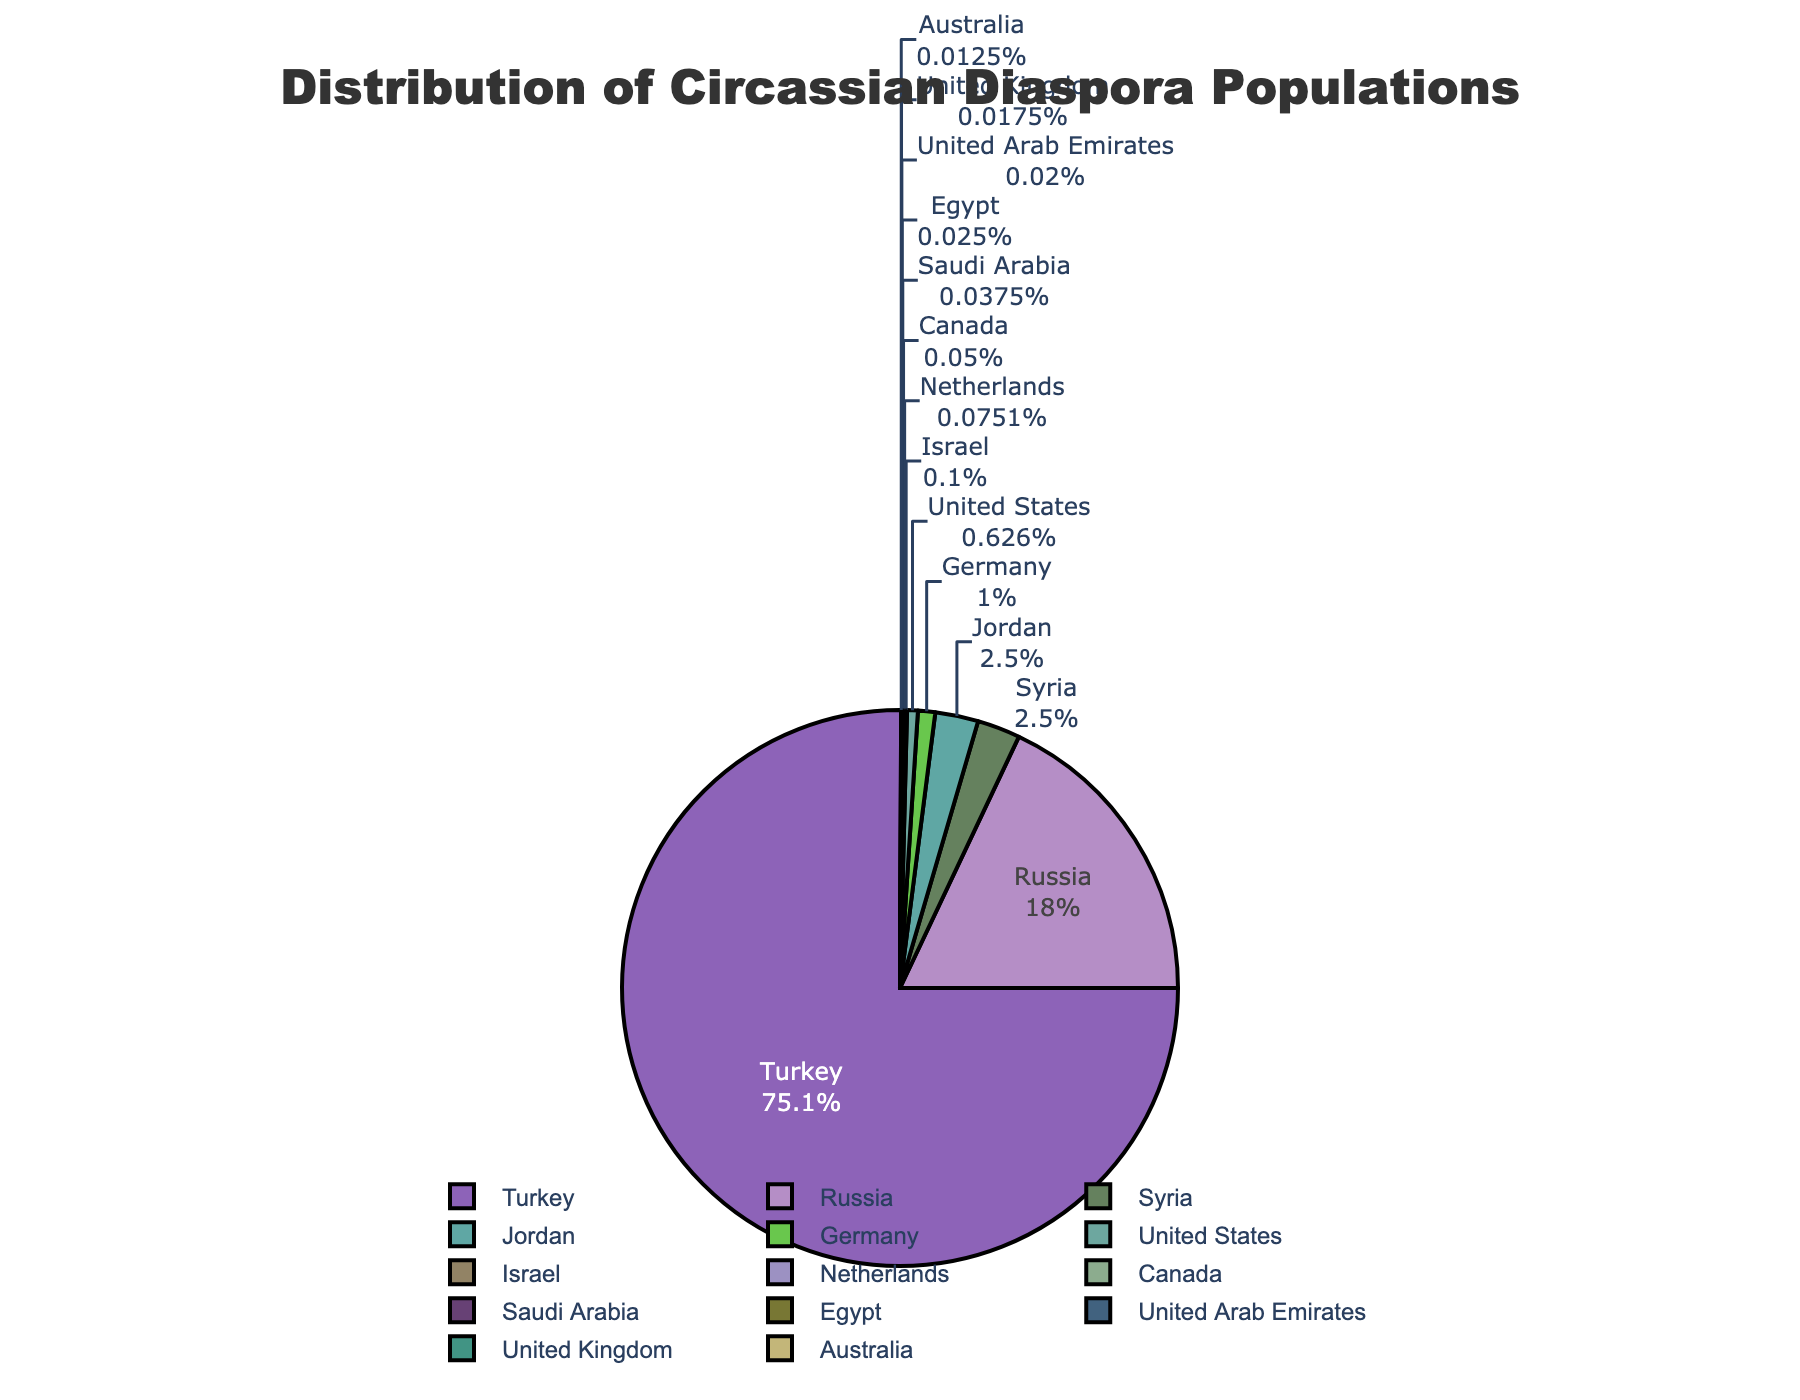what's the percentage of the Circassian population living in Turkey? Based on the pie chart, identify the segment labeled 'Turkey' and note the percentage value displayed.
Answer: Approximately 76.74% Which country has the second largest Circassian diaspora population? By visually assessing the sizes of the different segments in the pie chart, locate the segment representing the second largest value. This segment should be labeled 'Russia'.
Answer: Russia How does the Circassian population in Syria compare to that in Jordan? Find the segments labeled 'Syria' and 'Jordan'. Compare the sizes of these segments to see if they are equal. Both segments should be nearly identical.
Answer: Equal What is the combined Circassian population in Germany and the United States? Identify the segments labeled 'Germany' and 'United States', note their populations (40,000 for Germany and 25,000 for the United States), then sum these values (40,000 + 25,000).
Answer: 65,000 What proportion of the Circassian diaspora population resides in countries with over 500,000 people? Find segments labelled Turkey and Russia. Note their percentages. Turkey has 76.74%, Russia has 18.37%. Sum these percentages: 76.74% + 18.37% = 95.11%.
Answer: 95.11% 